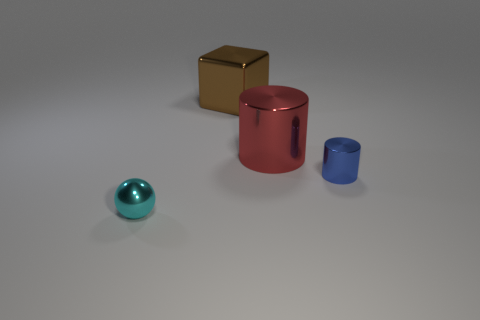What can you infer about the texture of the objects? The objects appear to have different textures. The red and blue cylinders have a matte finish, while the gold cube and teal sphere have reflective surfaces, indicating a smoother texture. Which of these textures would likely feel cooler to the touch? The smooth, reflective surfaces of the gold cube and the teal sphere would likely feel cooler to the touch compared to the matte surfaces of the red and blue cylinders. 